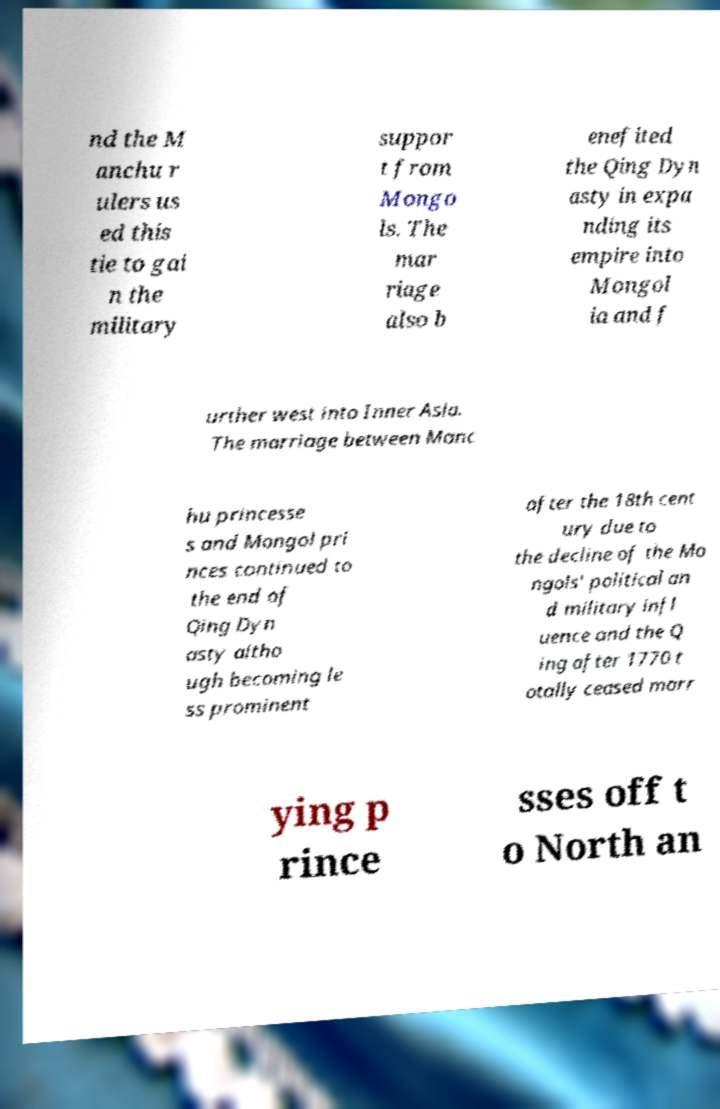Please identify and transcribe the text found in this image. nd the M anchu r ulers us ed this tie to gai n the military suppor t from Mongo ls. The mar riage also b enefited the Qing Dyn asty in expa nding its empire into Mongol ia and f urther west into Inner Asia. The marriage between Manc hu princesse s and Mongol pri nces continued to the end of Qing Dyn asty altho ugh becoming le ss prominent after the 18th cent ury due to the decline of the Mo ngols' political an d military infl uence and the Q ing after 1770 t otally ceased marr ying p rince sses off t o North an 